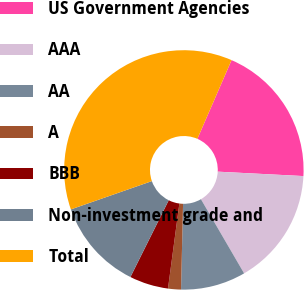<chart> <loc_0><loc_0><loc_500><loc_500><pie_chart><fcel>US Government Agencies<fcel>AAA<fcel>AA<fcel>A<fcel>BBB<fcel>Non-investment grade and<fcel>Total<nl><fcel>19.3%<fcel>15.79%<fcel>8.77%<fcel>1.74%<fcel>5.25%<fcel>12.28%<fcel>36.87%<nl></chart> 